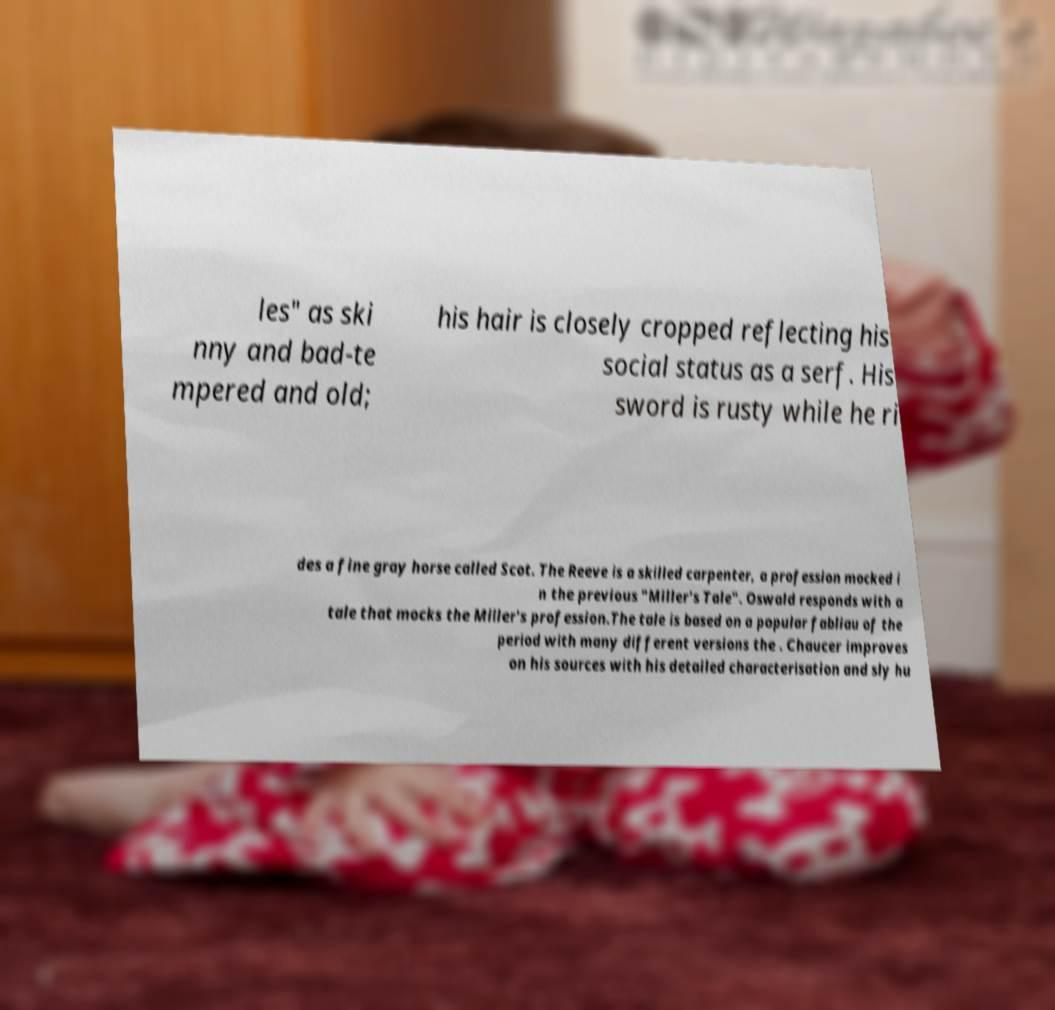Can you read and provide the text displayed in the image?This photo seems to have some interesting text. Can you extract and type it out for me? les" as ski nny and bad-te mpered and old; his hair is closely cropped reflecting his social status as a serf. His sword is rusty while he ri des a fine gray horse called Scot. The Reeve is a skilled carpenter, a profession mocked i n the previous "Miller's Tale". Oswald responds with a tale that mocks the Miller's profession.The tale is based on a popular fabliau of the period with many different versions the . Chaucer improves on his sources with his detailed characterisation and sly hu 